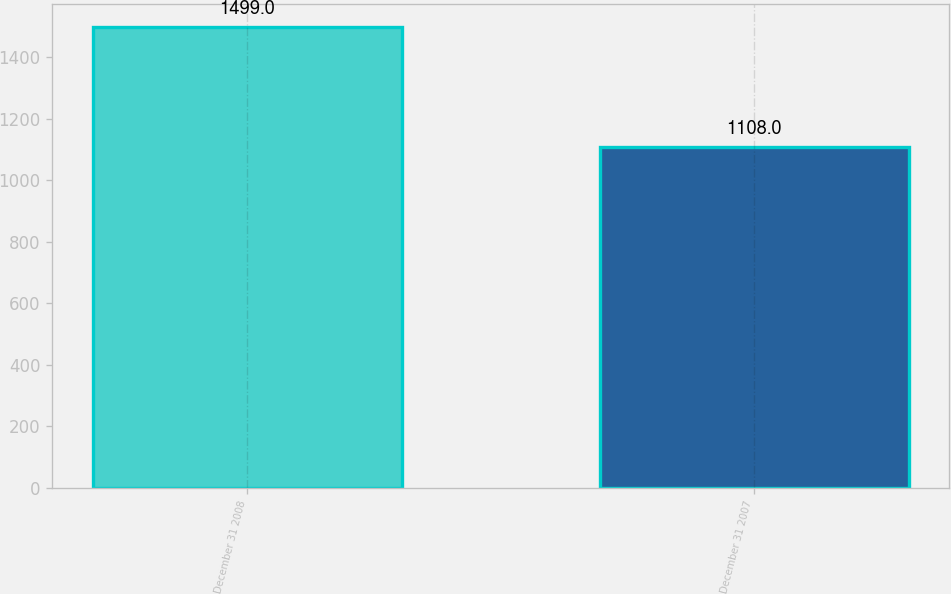Convert chart. <chart><loc_0><loc_0><loc_500><loc_500><bar_chart><fcel>December 31 2008<fcel>December 31 2007<nl><fcel>1499<fcel>1108<nl></chart> 